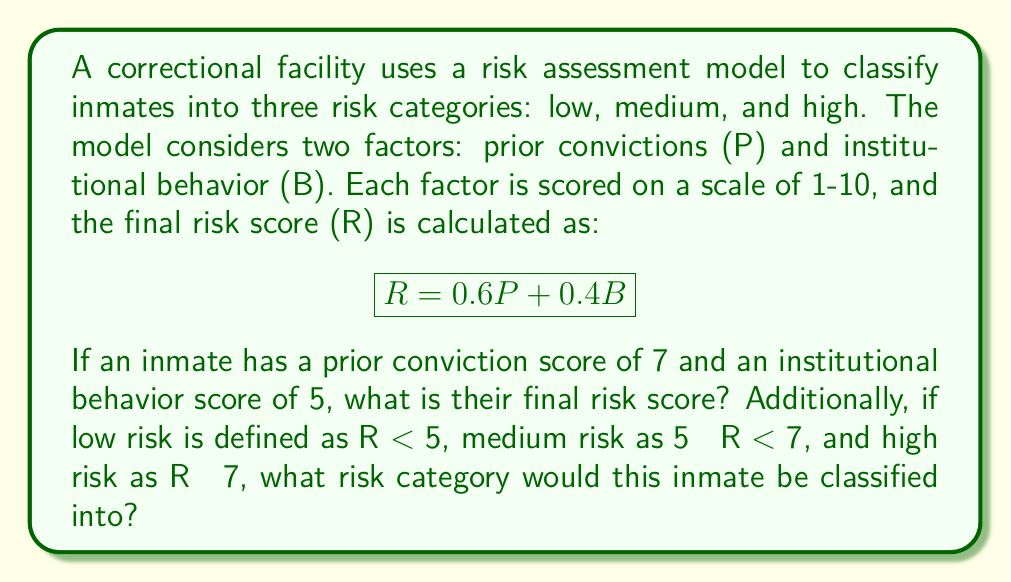What is the answer to this math problem? To solve this problem, we'll follow these steps:

1. Calculate the final risk score (R) using the given formula and scores.
2. Determine the risk category based on the calculated score.

Step 1: Calculating the final risk score

Given:
- Prior conviction score (P) = 7
- Institutional behavior score (B) = 5
- Risk score formula: $R = 0.6P + 0.4B$

Let's substitute the values into the formula:

$$ R = 0.6(7) + 0.4(5) $$
$$ R = 4.2 + 2.0 $$
$$ R = 6.2 $$

Step 2: Determining the risk category

The risk categories are defined as:
- Low risk: R < 5
- Medium risk: 5 ≤ R < 7
- High risk: R ≥ 7

Since the calculated risk score R = 6.2, it falls within the medium risk category (5 ≤ 6.2 < 7).
Answer: The inmate's final risk score is 6.2, and they would be classified into the medium risk category. 